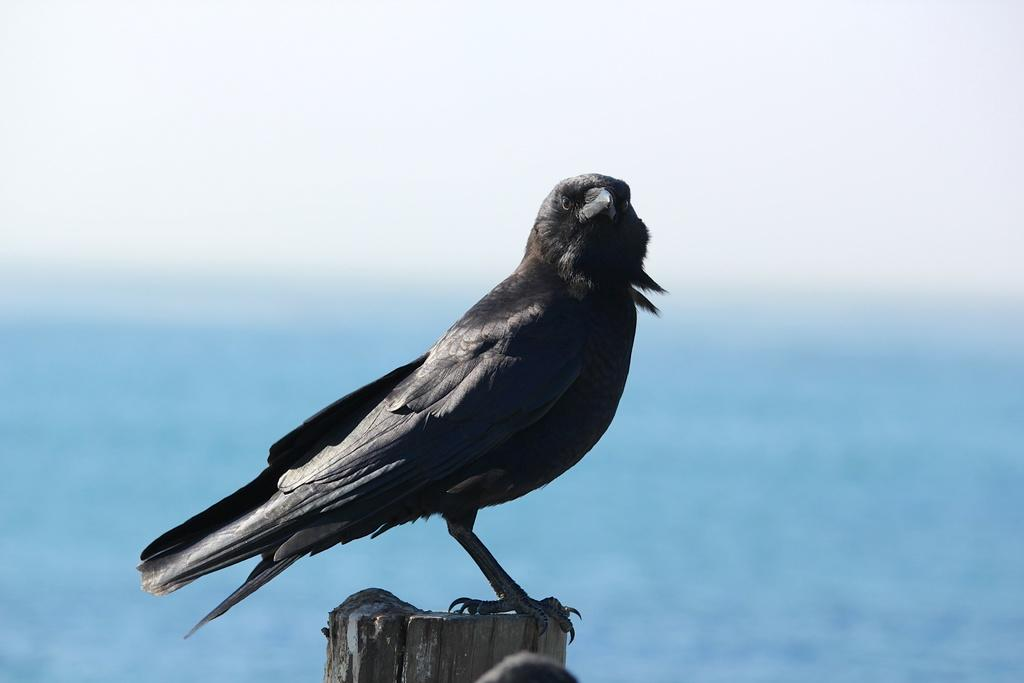What animal is present on the wood in the image? There is a bird on the wood in the image. What can be seen in the background of the image? The background of the image includes sky and water. What type of experience can be seen in the image? There is no experience depicted in the image; it features a bird on wood with a sky and water background. Can you see any flames in the image? No, there are no flames present in the image. 